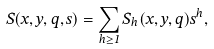<formula> <loc_0><loc_0><loc_500><loc_500>S ( x , y , q , s ) = \sum _ { h \geq 1 } S _ { h } ( x , y , q ) s ^ { h } ,</formula> 